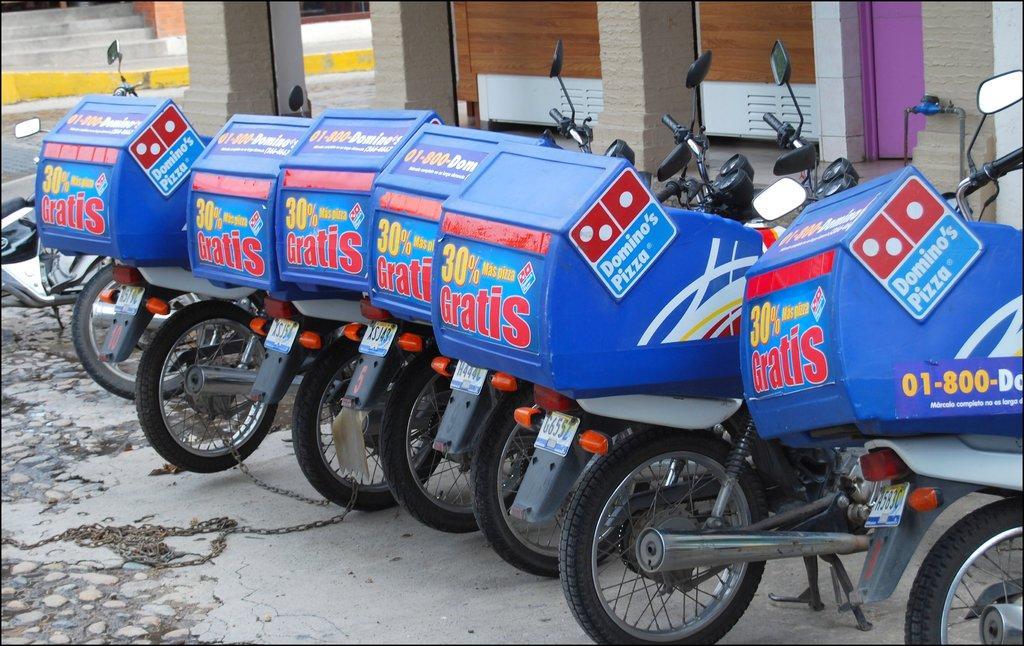Please provide a concise description of this image. In this picture, we see many bikes with blue color boxes are parked on the road. On the boxes, we see text written as "DOMINO'S PIZZA". In the background, we see pillars and a building in white and brown color. We even see a pink door and staircase. In the left top of the picture, we see a staircase. 